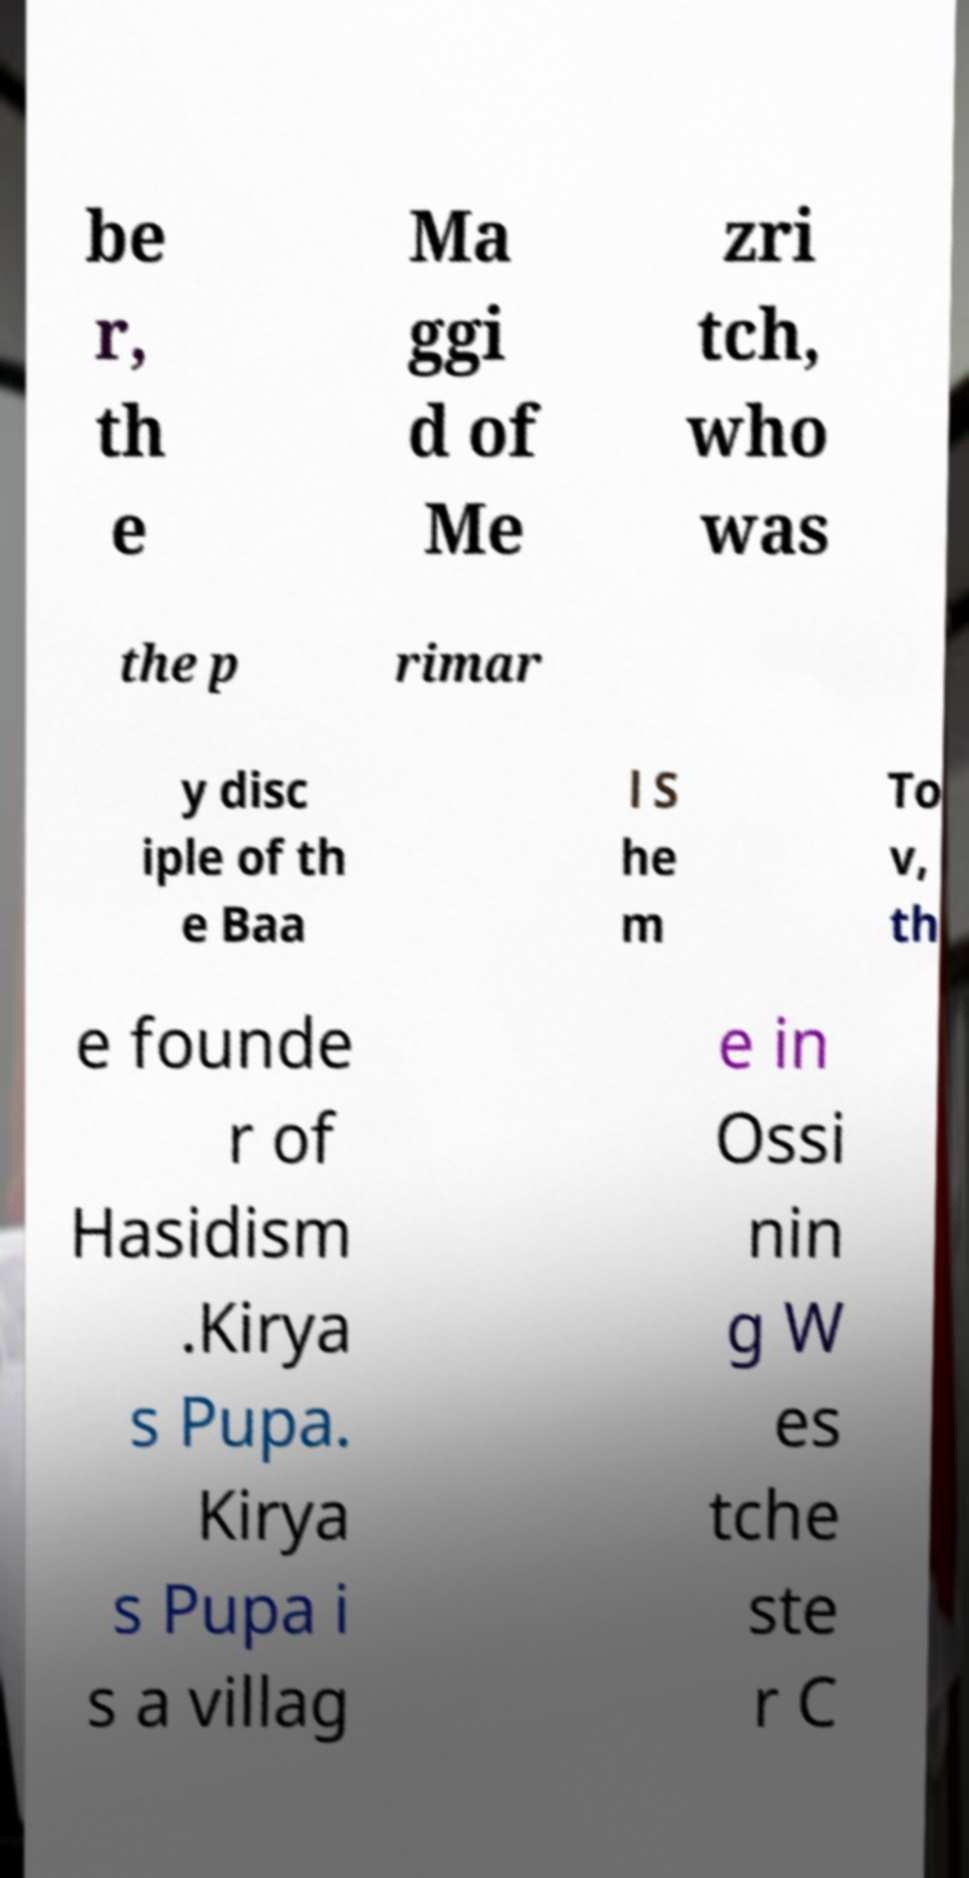What messages or text are displayed in this image? I need them in a readable, typed format. be r, th e Ma ggi d of Me zri tch, who was the p rimar y disc iple of th e Baa l S he m To v, th e founde r of Hasidism .Kirya s Pupa. Kirya s Pupa i s a villag e in Ossi nin g W es tche ste r C 